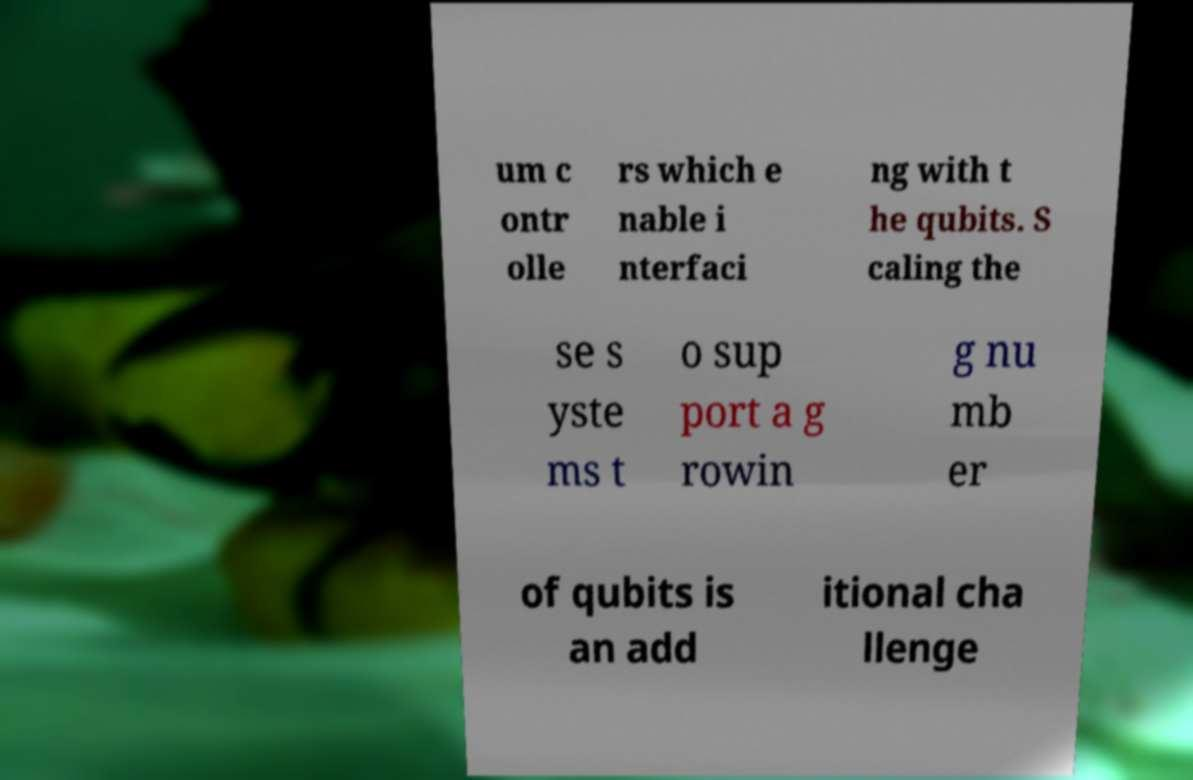Can you accurately transcribe the text from the provided image for me? um c ontr olle rs which e nable i nterfaci ng with t he qubits. S caling the se s yste ms t o sup port a g rowin g nu mb er of qubits is an add itional cha llenge 